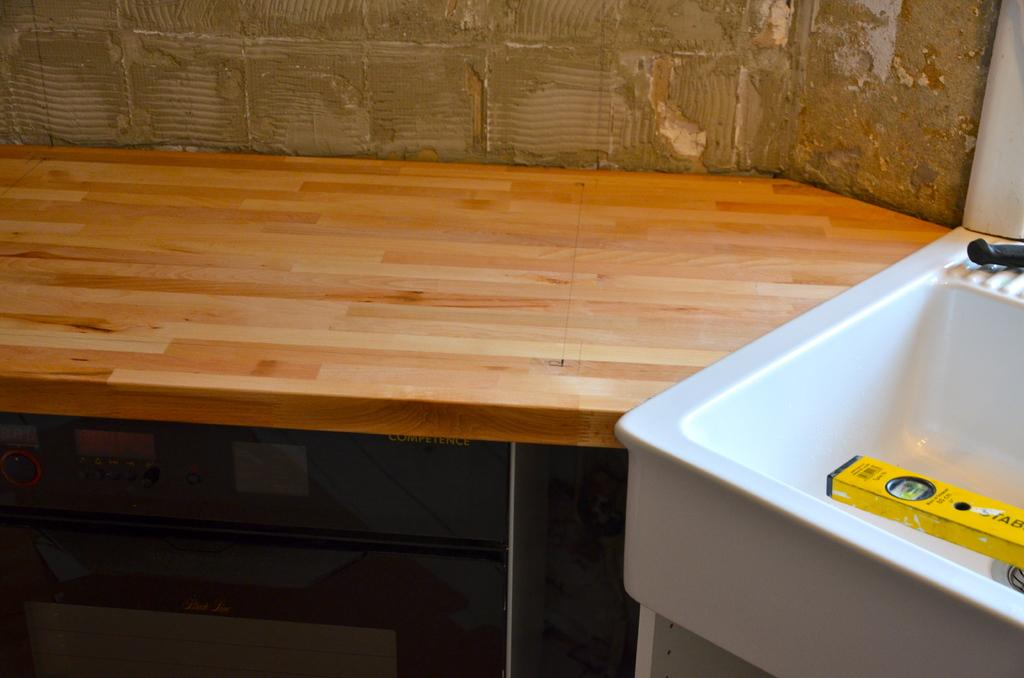What type of desk is in the image? There is a brown desk in the image. What is located on the right side of the image? There is a white sink on the right side of the image. What can be seen in the background of the image? There is a wall in the background of the image. Can you touch the existence of the desk in the image? The question is unclear and seems to mix concepts. The desk is visible in the image, but it is not possible to touch it through the image. The concept of "touching the existence" is not applicable in this context. 